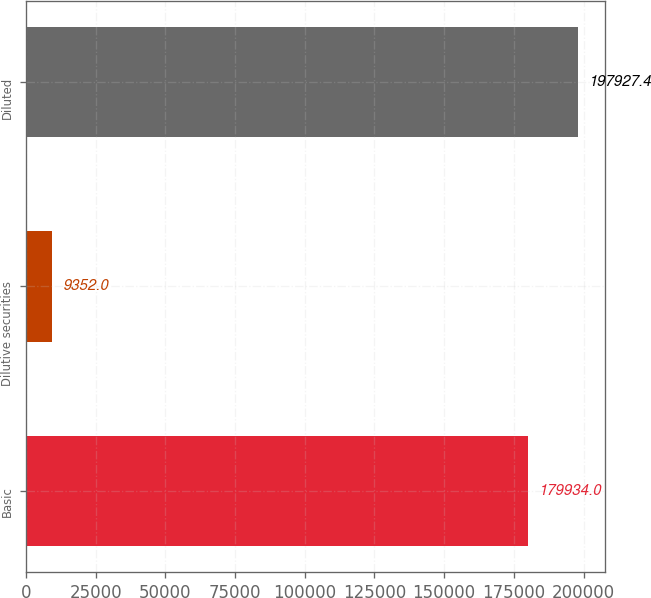<chart> <loc_0><loc_0><loc_500><loc_500><bar_chart><fcel>Basic<fcel>Dilutive securities<fcel>Diluted<nl><fcel>179934<fcel>9352<fcel>197927<nl></chart> 